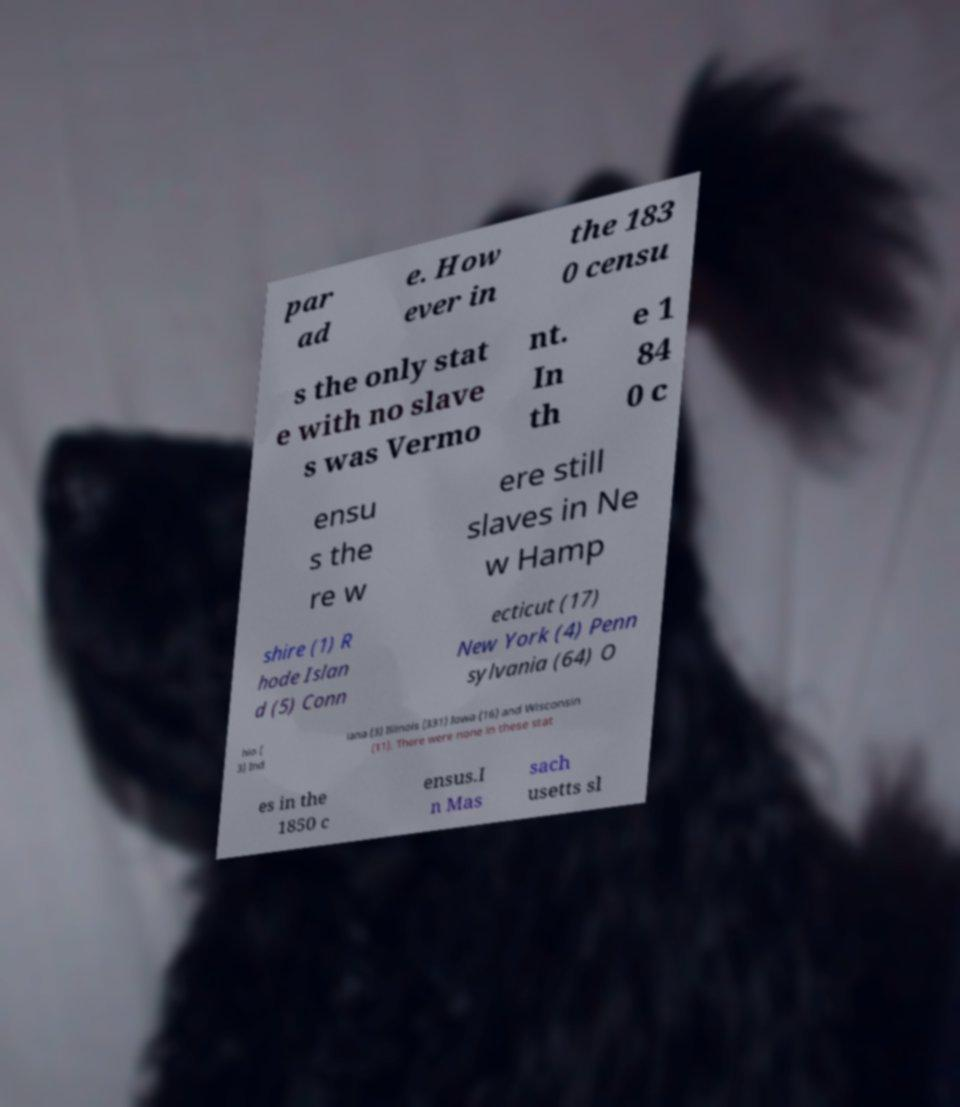Please identify and transcribe the text found in this image. par ad e. How ever in the 183 0 censu s the only stat e with no slave s was Vermo nt. In th e 1 84 0 c ensu s the re w ere still slaves in Ne w Hamp shire (1) R hode Islan d (5) Conn ecticut (17) New York (4) Penn sylvania (64) O hio ( 3) Ind iana (3) Illinois (331) Iowa (16) and Wisconsin (11). There were none in these stat es in the 1850 c ensus.I n Mas sach usetts sl 